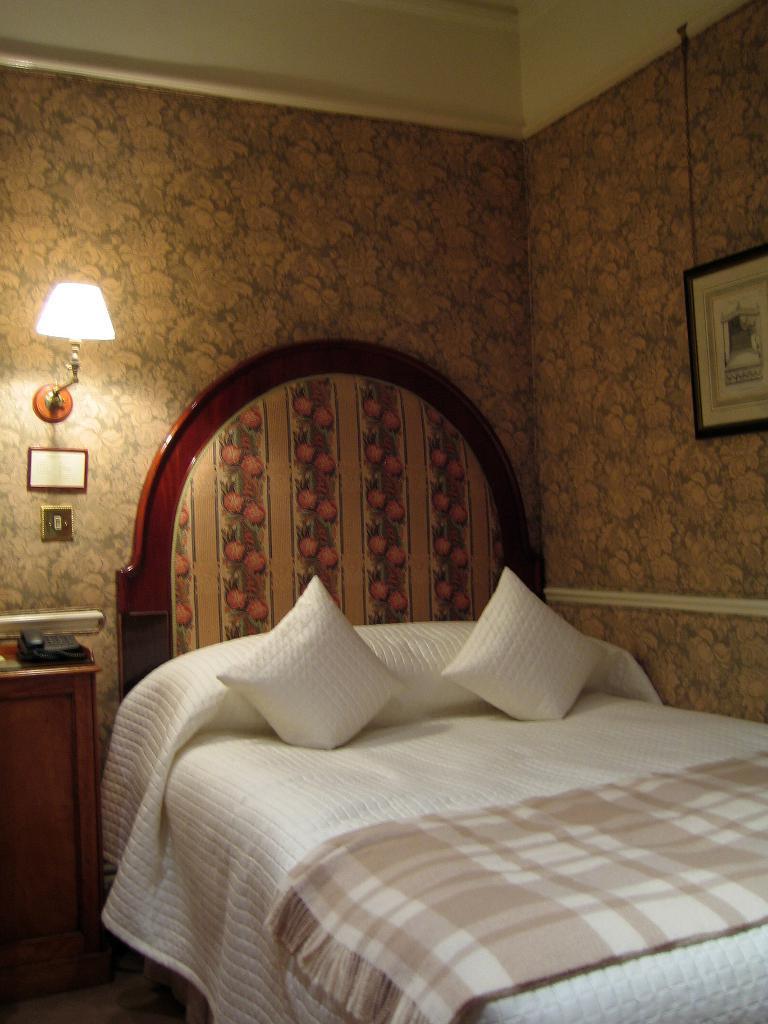In one or two sentences, can you explain what this image depicts? The image is inside the room. In the image there is a bed, on bed we can see two pillows and a blanket on right side there is a photo frame on wall. On left side we can see a lamp and a table, on table there is a land mobile. 